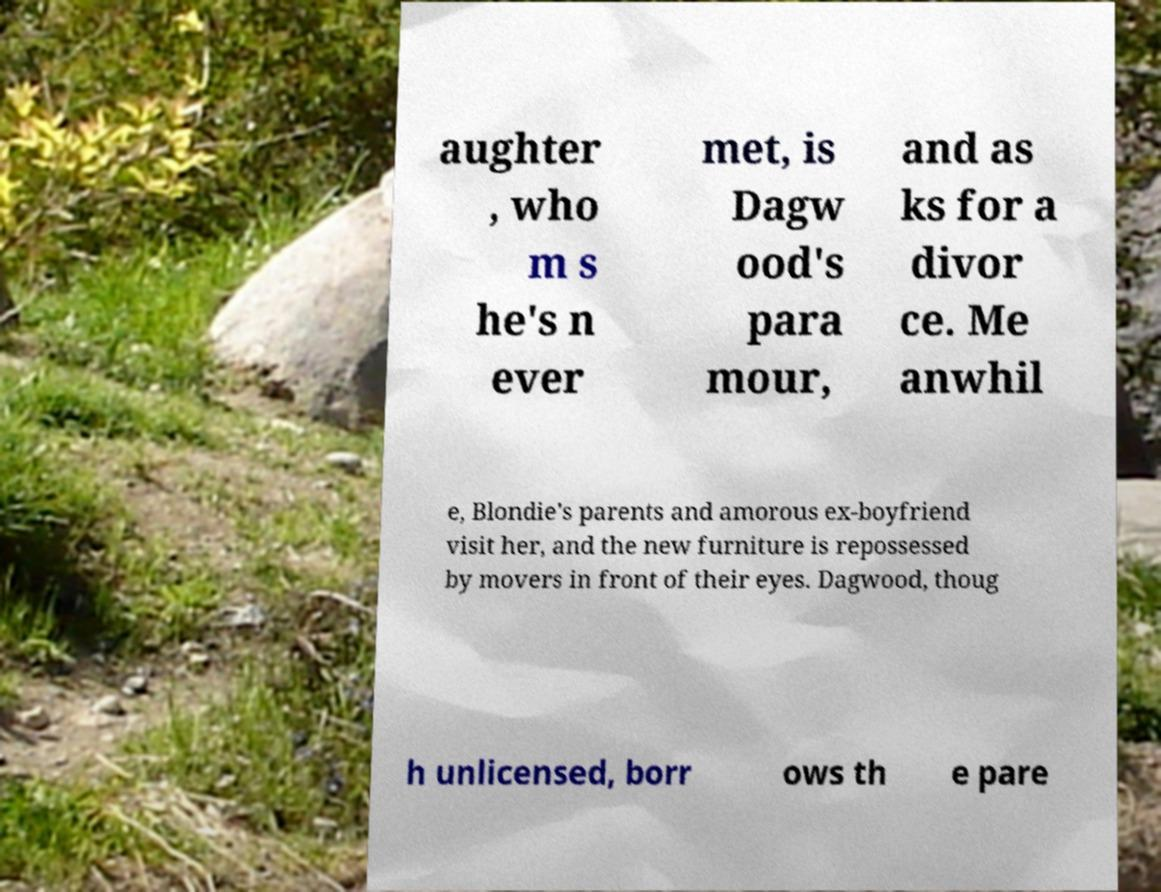Please read and relay the text visible in this image. What does it say? aughter , who m s he's n ever met, is Dagw ood's para mour, and as ks for a divor ce. Me anwhil e, Blondie's parents and amorous ex-boyfriend visit her, and the new furniture is repossessed by movers in front of their eyes. Dagwood, thoug h unlicensed, borr ows th e pare 